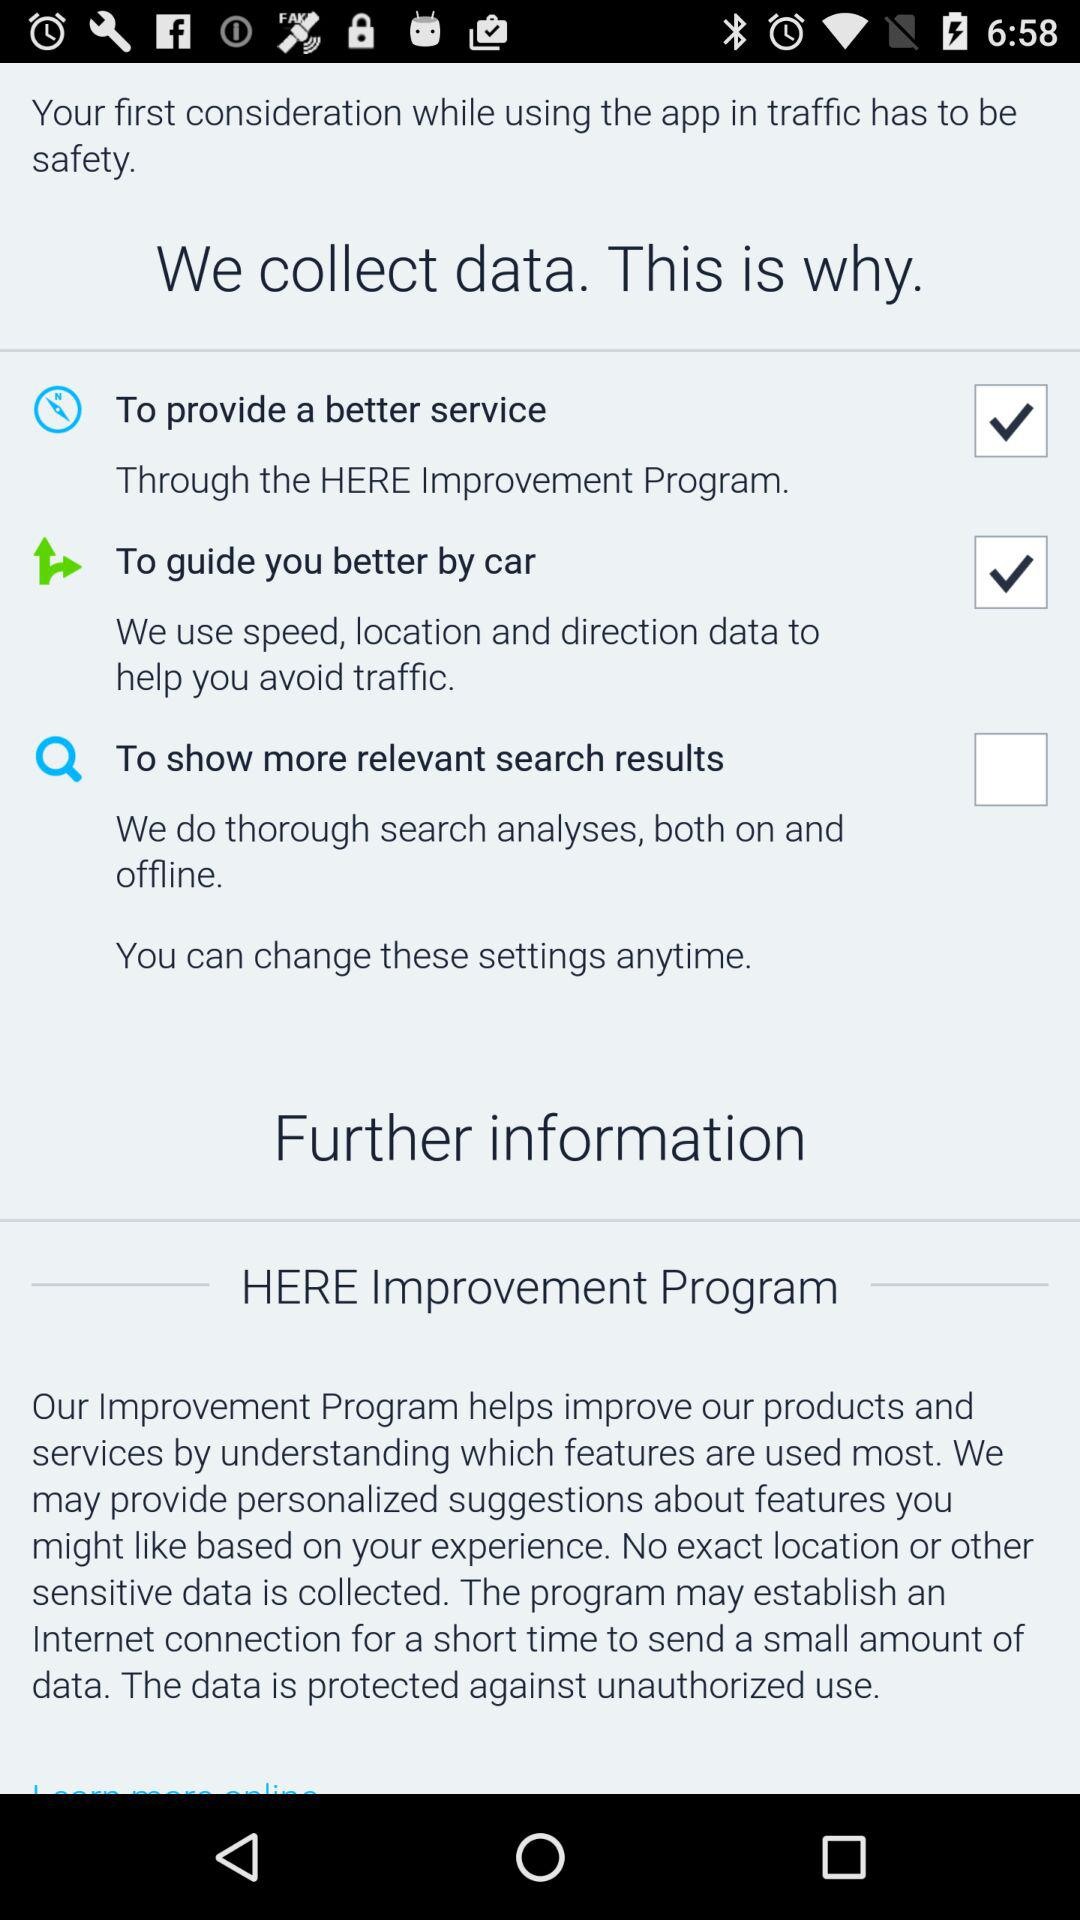Which option is selected? The selected options are "To provide a better service" and "To guide you better by car". 